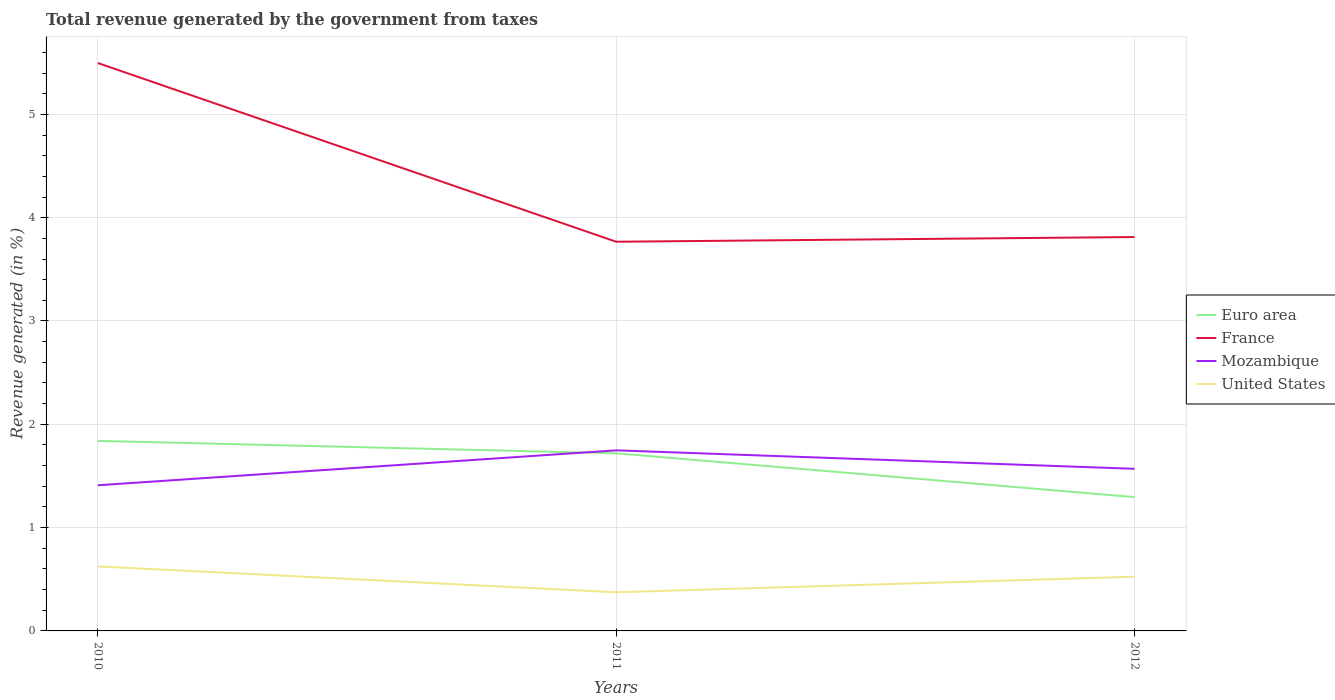How many different coloured lines are there?
Provide a short and direct response. 4. Across all years, what is the maximum total revenue generated in Euro area?
Your answer should be very brief. 1.3. What is the total total revenue generated in Mozambique in the graph?
Your response must be concise. -0.34. What is the difference between the highest and the second highest total revenue generated in United States?
Offer a very short reply. 0.25. What is the difference between the highest and the lowest total revenue generated in France?
Offer a terse response. 1. How many years are there in the graph?
Offer a terse response. 3. What is the difference between two consecutive major ticks on the Y-axis?
Provide a short and direct response. 1. Does the graph contain grids?
Offer a very short reply. Yes. Where does the legend appear in the graph?
Make the answer very short. Center right. How are the legend labels stacked?
Offer a terse response. Vertical. What is the title of the graph?
Your answer should be very brief. Total revenue generated by the government from taxes. What is the label or title of the Y-axis?
Ensure brevity in your answer.  Revenue generated (in %). What is the Revenue generated (in %) in Euro area in 2010?
Your response must be concise. 1.84. What is the Revenue generated (in %) of France in 2010?
Make the answer very short. 5.5. What is the Revenue generated (in %) in Mozambique in 2010?
Provide a succinct answer. 1.41. What is the Revenue generated (in %) of United States in 2010?
Your answer should be compact. 0.62. What is the Revenue generated (in %) of Euro area in 2011?
Your answer should be compact. 1.72. What is the Revenue generated (in %) of France in 2011?
Ensure brevity in your answer.  3.77. What is the Revenue generated (in %) of Mozambique in 2011?
Your answer should be compact. 1.75. What is the Revenue generated (in %) of United States in 2011?
Your response must be concise. 0.37. What is the Revenue generated (in %) in Euro area in 2012?
Your answer should be compact. 1.3. What is the Revenue generated (in %) of France in 2012?
Your answer should be very brief. 3.81. What is the Revenue generated (in %) in Mozambique in 2012?
Your answer should be very brief. 1.57. What is the Revenue generated (in %) of United States in 2012?
Ensure brevity in your answer.  0.52. Across all years, what is the maximum Revenue generated (in %) in Euro area?
Give a very brief answer. 1.84. Across all years, what is the maximum Revenue generated (in %) in France?
Ensure brevity in your answer.  5.5. Across all years, what is the maximum Revenue generated (in %) of Mozambique?
Provide a succinct answer. 1.75. Across all years, what is the maximum Revenue generated (in %) in United States?
Your answer should be compact. 0.62. Across all years, what is the minimum Revenue generated (in %) of Euro area?
Keep it short and to the point. 1.3. Across all years, what is the minimum Revenue generated (in %) in France?
Offer a terse response. 3.77. Across all years, what is the minimum Revenue generated (in %) in Mozambique?
Offer a terse response. 1.41. Across all years, what is the minimum Revenue generated (in %) in United States?
Give a very brief answer. 0.37. What is the total Revenue generated (in %) of Euro area in the graph?
Your answer should be compact. 4.85. What is the total Revenue generated (in %) of France in the graph?
Provide a short and direct response. 13.08. What is the total Revenue generated (in %) of Mozambique in the graph?
Give a very brief answer. 4.73. What is the total Revenue generated (in %) in United States in the graph?
Your answer should be compact. 1.52. What is the difference between the Revenue generated (in %) in Euro area in 2010 and that in 2011?
Give a very brief answer. 0.12. What is the difference between the Revenue generated (in %) of France in 2010 and that in 2011?
Give a very brief answer. 1.73. What is the difference between the Revenue generated (in %) of Mozambique in 2010 and that in 2011?
Give a very brief answer. -0.34. What is the difference between the Revenue generated (in %) in United States in 2010 and that in 2011?
Your answer should be compact. 0.25. What is the difference between the Revenue generated (in %) in Euro area in 2010 and that in 2012?
Give a very brief answer. 0.54. What is the difference between the Revenue generated (in %) in France in 2010 and that in 2012?
Provide a short and direct response. 1.68. What is the difference between the Revenue generated (in %) in Mozambique in 2010 and that in 2012?
Offer a terse response. -0.16. What is the difference between the Revenue generated (in %) in United States in 2010 and that in 2012?
Your answer should be very brief. 0.1. What is the difference between the Revenue generated (in %) in Euro area in 2011 and that in 2012?
Provide a succinct answer. 0.42. What is the difference between the Revenue generated (in %) of France in 2011 and that in 2012?
Provide a short and direct response. -0.05. What is the difference between the Revenue generated (in %) of Mozambique in 2011 and that in 2012?
Make the answer very short. 0.18. What is the difference between the Revenue generated (in %) in United States in 2011 and that in 2012?
Make the answer very short. -0.15. What is the difference between the Revenue generated (in %) of Euro area in 2010 and the Revenue generated (in %) of France in 2011?
Give a very brief answer. -1.93. What is the difference between the Revenue generated (in %) in Euro area in 2010 and the Revenue generated (in %) in Mozambique in 2011?
Provide a succinct answer. 0.09. What is the difference between the Revenue generated (in %) of Euro area in 2010 and the Revenue generated (in %) of United States in 2011?
Provide a short and direct response. 1.47. What is the difference between the Revenue generated (in %) of France in 2010 and the Revenue generated (in %) of Mozambique in 2011?
Offer a terse response. 3.75. What is the difference between the Revenue generated (in %) in France in 2010 and the Revenue generated (in %) in United States in 2011?
Provide a succinct answer. 5.12. What is the difference between the Revenue generated (in %) of Mozambique in 2010 and the Revenue generated (in %) of United States in 2011?
Offer a terse response. 1.04. What is the difference between the Revenue generated (in %) of Euro area in 2010 and the Revenue generated (in %) of France in 2012?
Your response must be concise. -1.97. What is the difference between the Revenue generated (in %) of Euro area in 2010 and the Revenue generated (in %) of Mozambique in 2012?
Ensure brevity in your answer.  0.27. What is the difference between the Revenue generated (in %) in Euro area in 2010 and the Revenue generated (in %) in United States in 2012?
Offer a very short reply. 1.31. What is the difference between the Revenue generated (in %) of France in 2010 and the Revenue generated (in %) of Mozambique in 2012?
Make the answer very short. 3.93. What is the difference between the Revenue generated (in %) in France in 2010 and the Revenue generated (in %) in United States in 2012?
Give a very brief answer. 4.97. What is the difference between the Revenue generated (in %) in Mozambique in 2010 and the Revenue generated (in %) in United States in 2012?
Provide a succinct answer. 0.89. What is the difference between the Revenue generated (in %) in Euro area in 2011 and the Revenue generated (in %) in France in 2012?
Keep it short and to the point. -2.09. What is the difference between the Revenue generated (in %) in Euro area in 2011 and the Revenue generated (in %) in Mozambique in 2012?
Provide a short and direct response. 0.15. What is the difference between the Revenue generated (in %) in Euro area in 2011 and the Revenue generated (in %) in United States in 2012?
Your answer should be compact. 1.19. What is the difference between the Revenue generated (in %) of France in 2011 and the Revenue generated (in %) of Mozambique in 2012?
Keep it short and to the point. 2.2. What is the difference between the Revenue generated (in %) in France in 2011 and the Revenue generated (in %) in United States in 2012?
Your answer should be very brief. 3.24. What is the difference between the Revenue generated (in %) in Mozambique in 2011 and the Revenue generated (in %) in United States in 2012?
Your answer should be compact. 1.22. What is the average Revenue generated (in %) of Euro area per year?
Give a very brief answer. 1.62. What is the average Revenue generated (in %) in France per year?
Provide a short and direct response. 4.36. What is the average Revenue generated (in %) in Mozambique per year?
Ensure brevity in your answer.  1.58. What is the average Revenue generated (in %) of United States per year?
Provide a short and direct response. 0.51. In the year 2010, what is the difference between the Revenue generated (in %) of Euro area and Revenue generated (in %) of France?
Provide a succinct answer. -3.66. In the year 2010, what is the difference between the Revenue generated (in %) in Euro area and Revenue generated (in %) in Mozambique?
Give a very brief answer. 0.43. In the year 2010, what is the difference between the Revenue generated (in %) in Euro area and Revenue generated (in %) in United States?
Provide a short and direct response. 1.22. In the year 2010, what is the difference between the Revenue generated (in %) of France and Revenue generated (in %) of Mozambique?
Your response must be concise. 4.09. In the year 2010, what is the difference between the Revenue generated (in %) in France and Revenue generated (in %) in United States?
Your answer should be very brief. 4.87. In the year 2010, what is the difference between the Revenue generated (in %) of Mozambique and Revenue generated (in %) of United States?
Make the answer very short. 0.79. In the year 2011, what is the difference between the Revenue generated (in %) in Euro area and Revenue generated (in %) in France?
Offer a very short reply. -2.05. In the year 2011, what is the difference between the Revenue generated (in %) in Euro area and Revenue generated (in %) in Mozambique?
Offer a very short reply. -0.03. In the year 2011, what is the difference between the Revenue generated (in %) of Euro area and Revenue generated (in %) of United States?
Offer a terse response. 1.35. In the year 2011, what is the difference between the Revenue generated (in %) in France and Revenue generated (in %) in Mozambique?
Give a very brief answer. 2.02. In the year 2011, what is the difference between the Revenue generated (in %) of France and Revenue generated (in %) of United States?
Your answer should be very brief. 3.39. In the year 2011, what is the difference between the Revenue generated (in %) of Mozambique and Revenue generated (in %) of United States?
Offer a terse response. 1.37. In the year 2012, what is the difference between the Revenue generated (in %) in Euro area and Revenue generated (in %) in France?
Provide a succinct answer. -2.52. In the year 2012, what is the difference between the Revenue generated (in %) of Euro area and Revenue generated (in %) of Mozambique?
Offer a terse response. -0.27. In the year 2012, what is the difference between the Revenue generated (in %) of Euro area and Revenue generated (in %) of United States?
Your answer should be very brief. 0.77. In the year 2012, what is the difference between the Revenue generated (in %) in France and Revenue generated (in %) in Mozambique?
Keep it short and to the point. 2.24. In the year 2012, what is the difference between the Revenue generated (in %) in France and Revenue generated (in %) in United States?
Your answer should be compact. 3.29. In the year 2012, what is the difference between the Revenue generated (in %) in Mozambique and Revenue generated (in %) in United States?
Offer a terse response. 1.04. What is the ratio of the Revenue generated (in %) of Euro area in 2010 to that in 2011?
Your answer should be very brief. 1.07. What is the ratio of the Revenue generated (in %) in France in 2010 to that in 2011?
Offer a terse response. 1.46. What is the ratio of the Revenue generated (in %) in Mozambique in 2010 to that in 2011?
Give a very brief answer. 0.81. What is the ratio of the Revenue generated (in %) of United States in 2010 to that in 2011?
Provide a short and direct response. 1.67. What is the ratio of the Revenue generated (in %) in Euro area in 2010 to that in 2012?
Your answer should be very brief. 1.42. What is the ratio of the Revenue generated (in %) of France in 2010 to that in 2012?
Keep it short and to the point. 1.44. What is the ratio of the Revenue generated (in %) in Mozambique in 2010 to that in 2012?
Your answer should be very brief. 0.9. What is the ratio of the Revenue generated (in %) in United States in 2010 to that in 2012?
Give a very brief answer. 1.19. What is the ratio of the Revenue generated (in %) of Euro area in 2011 to that in 2012?
Ensure brevity in your answer.  1.33. What is the ratio of the Revenue generated (in %) in Mozambique in 2011 to that in 2012?
Provide a short and direct response. 1.11. What is the ratio of the Revenue generated (in %) in United States in 2011 to that in 2012?
Your response must be concise. 0.71. What is the difference between the highest and the second highest Revenue generated (in %) of Euro area?
Offer a terse response. 0.12. What is the difference between the highest and the second highest Revenue generated (in %) in France?
Your response must be concise. 1.68. What is the difference between the highest and the second highest Revenue generated (in %) of Mozambique?
Ensure brevity in your answer.  0.18. What is the difference between the highest and the second highest Revenue generated (in %) in United States?
Make the answer very short. 0.1. What is the difference between the highest and the lowest Revenue generated (in %) in Euro area?
Keep it short and to the point. 0.54. What is the difference between the highest and the lowest Revenue generated (in %) in France?
Your response must be concise. 1.73. What is the difference between the highest and the lowest Revenue generated (in %) of Mozambique?
Offer a very short reply. 0.34. What is the difference between the highest and the lowest Revenue generated (in %) of United States?
Give a very brief answer. 0.25. 